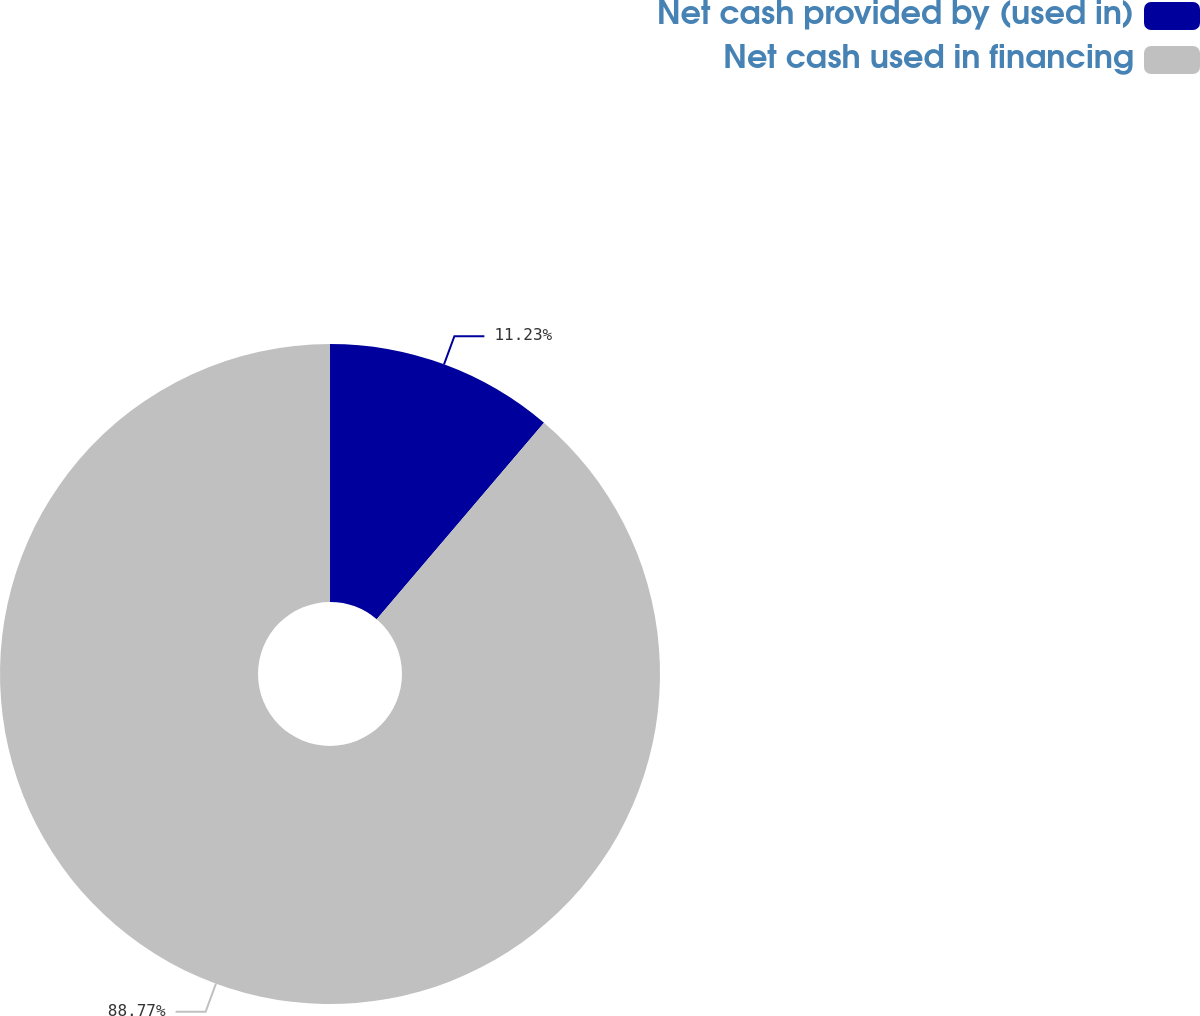Convert chart. <chart><loc_0><loc_0><loc_500><loc_500><pie_chart><fcel>Net cash provided by (used in)<fcel>Net cash used in financing<nl><fcel>11.23%<fcel>88.77%<nl></chart> 